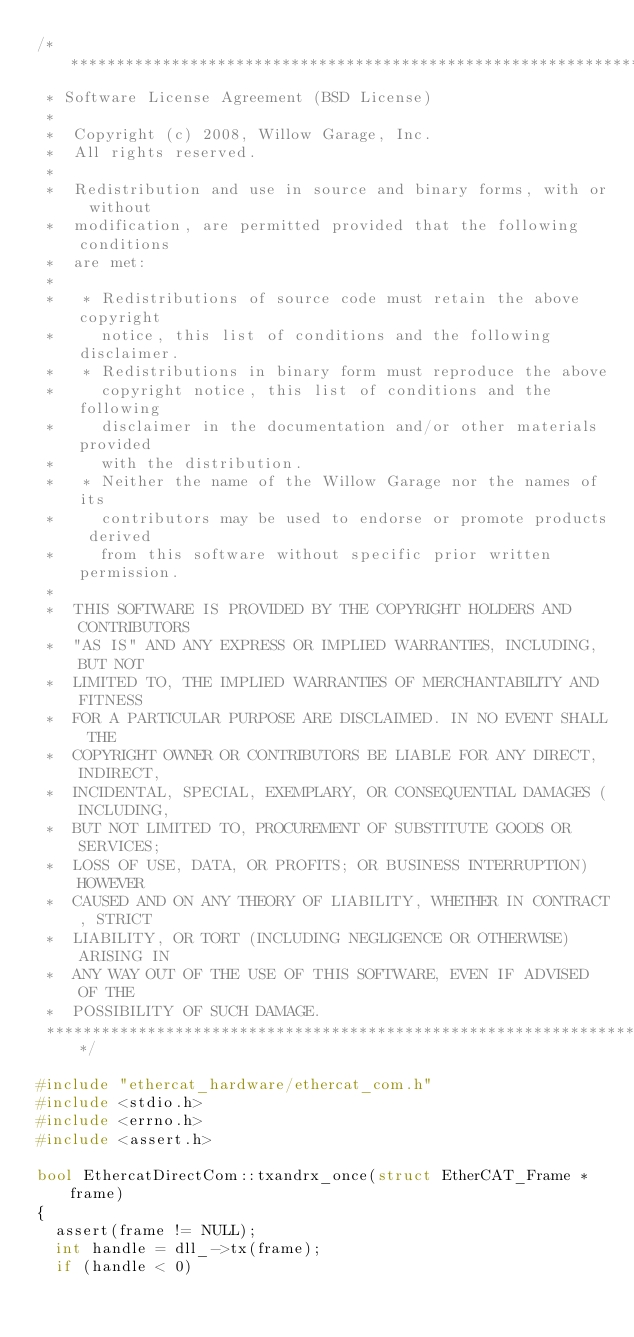<code> <loc_0><loc_0><loc_500><loc_500><_C++_>/*********************************************************************
 * Software License Agreement (BSD License)
 *
 *  Copyright (c) 2008, Willow Garage, Inc.
 *  All rights reserved.
 *
 *  Redistribution and use in source and binary forms, with or without
 *  modification, are permitted provided that the following conditions
 *  are met:
 *
 *   * Redistributions of source code must retain the above copyright
 *     notice, this list of conditions and the following disclaimer.
 *   * Redistributions in binary form must reproduce the above
 *     copyright notice, this list of conditions and the following
 *     disclaimer in the documentation and/or other materials provided
 *     with the distribution.
 *   * Neither the name of the Willow Garage nor the names of its
 *     contributors may be used to endorse or promote products derived
 *     from this software without specific prior written permission.
 *
 *  THIS SOFTWARE IS PROVIDED BY THE COPYRIGHT HOLDERS AND CONTRIBUTORS
 *  "AS IS" AND ANY EXPRESS OR IMPLIED WARRANTIES, INCLUDING, BUT NOT
 *  LIMITED TO, THE IMPLIED WARRANTIES OF MERCHANTABILITY AND FITNESS
 *  FOR A PARTICULAR PURPOSE ARE DISCLAIMED. IN NO EVENT SHALL THE
 *  COPYRIGHT OWNER OR CONTRIBUTORS BE LIABLE FOR ANY DIRECT, INDIRECT,
 *  INCIDENTAL, SPECIAL, EXEMPLARY, OR CONSEQUENTIAL DAMAGES (INCLUDING,
 *  BUT NOT LIMITED TO, PROCUREMENT OF SUBSTITUTE GOODS OR SERVICES;
 *  LOSS OF USE, DATA, OR PROFITS; OR BUSINESS INTERRUPTION) HOWEVER
 *  CAUSED AND ON ANY THEORY OF LIABILITY, WHETHER IN CONTRACT, STRICT
 *  LIABILITY, OR TORT (INCLUDING NEGLIGENCE OR OTHERWISE) ARISING IN
 *  ANY WAY OUT OF THE USE OF THIS SOFTWARE, EVEN IF ADVISED OF THE
 *  POSSIBILITY OF SUCH DAMAGE.
 *********************************************************************/

#include "ethercat_hardware/ethercat_com.h"
#include <stdio.h>
#include <errno.h>
#include <assert.h>

bool EthercatDirectCom::txandrx_once(struct EtherCAT_Frame * frame)
{
  assert(frame != NULL);
  int handle = dll_->tx(frame);
  if (handle < 0)</code> 